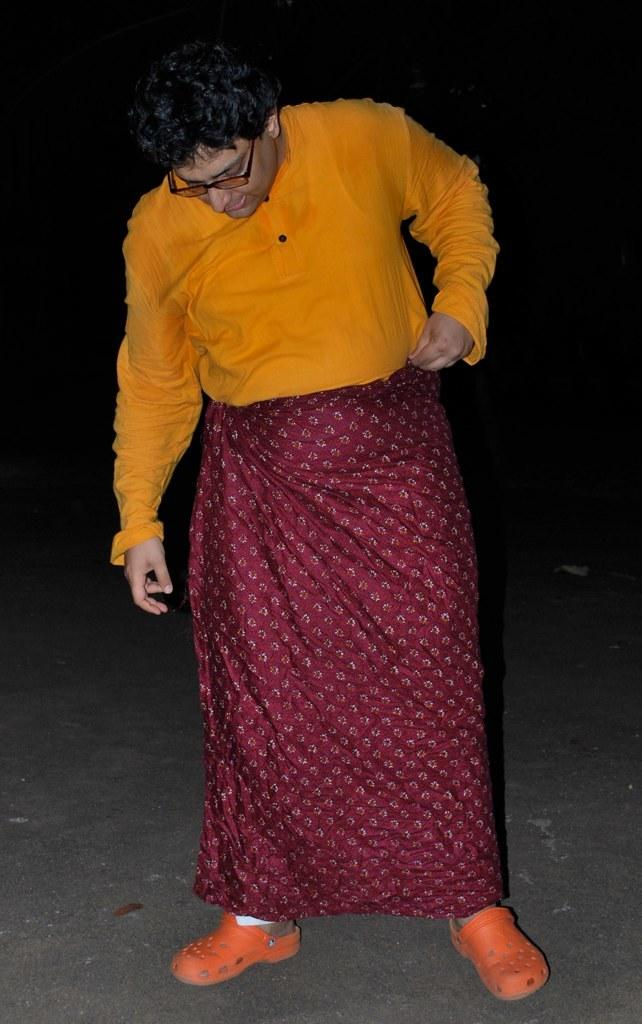What is the main subject in the foreground of the image? There is a person standing on the road in the foreground. What can be observed about the background of the image? The background of the image is dark in color. Based on the darkness of the background, can we infer the time of day when the image was taken? The image may have been taken during the night, as the background is dark. What type of hose can be seen on the floor in the image? There is no hose present on the floor in the image. Can you hear the person in the image laughing? The image is a still photograph, so we cannot hear any sounds, including laughter. 